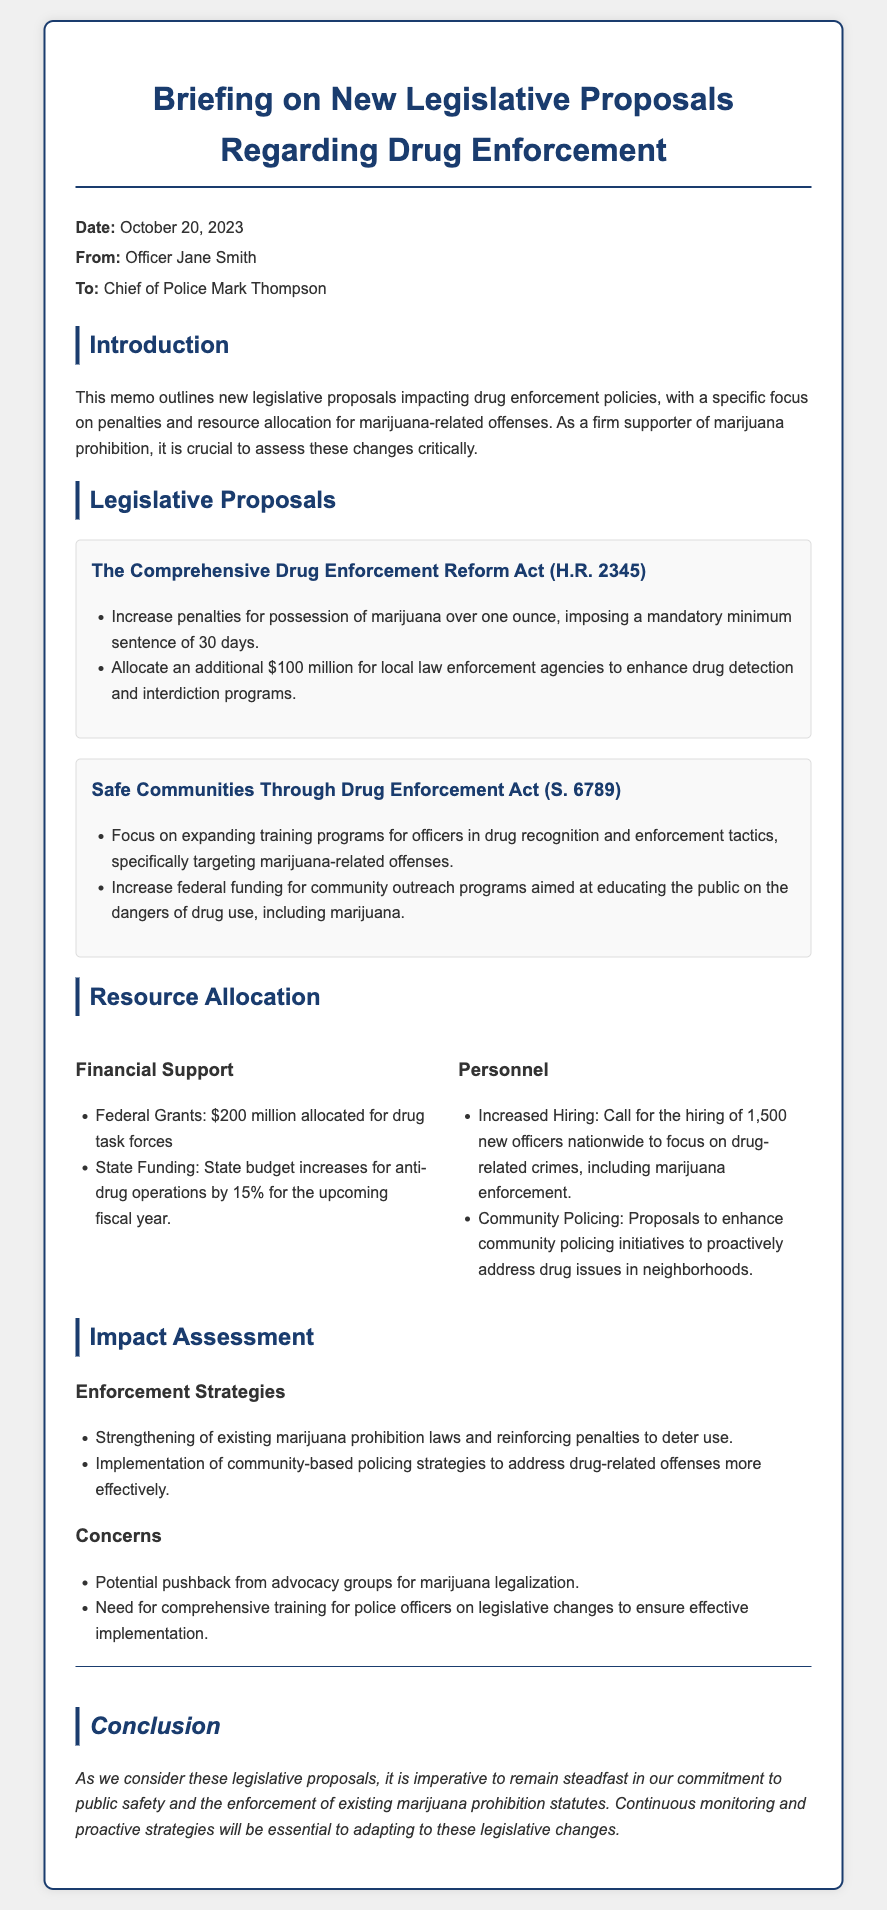What is the date of the memo? The date of the memo is mentioned in the header section, clearly stated as "October 20, 2023".
Answer: October 20, 2023 Who is the sender of the memo? The sender's name is provided in the "From" section of the header, which is Officer Jane Smith.
Answer: Officer Jane Smith What is the mandatory minimum sentence for possession of marijuana over one ounce? The mandatory minimum sentence is outlined in the legislative proposal section of the document as "30 days".
Answer: 30 days How much federal funding is allocated for community outreach programs? The document indicates an increase in federal funding for community outreach programs, specifically targeting education on drug dangers, including marijuana, without specifying the exact number.
Answer: Not specified How many new officers are proposed to be hired nationwide? The document states a call for the hiring of "1,500" new officers to focus on drug-related crimes, including marijuana enforcement.
Answer: 1,500 What is the total amount allocated for drug task forces? The financial support section details that "200 million" dollars is allocated for drug task forces.
Answer: 200 million What is the main concern regarding the proposed legislative changes? In the concerns section, one of the main concerns mentioned is the "Potential pushback from advocacy groups for marijuana legalization".
Answer: Potential pushback from advocacy groups for marijuana legalization What type of strategies are emphasized for enforcement? The document highlights that there will be a strengthening of existing marijuana prohibition laws as part of enforcement strategies.
Answer: Strengthening of existing marijuana prohibition laws What is the purpose of increasing training programs for officers? The purpose is described in the legislative proposals section, focusing on "drug recognition and enforcement tactics, specifically targeting marijuana-related offenses".
Answer: Drug recognition and enforcement tactics 